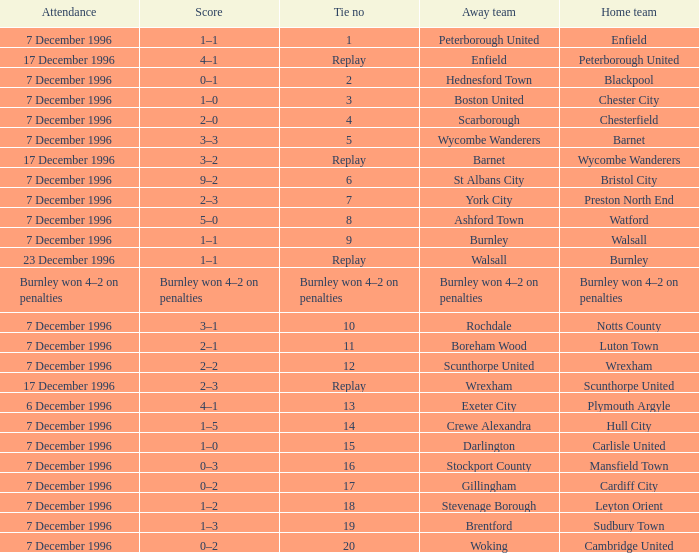What was the attendance for the home team of Walsall? 7 December 1996. 